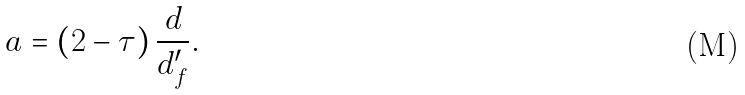Convert formula to latex. <formula><loc_0><loc_0><loc_500><loc_500>a = \left ( 2 - \tau \right ) \frac { d } { d _ { f } ^ { \prime } } .</formula> 